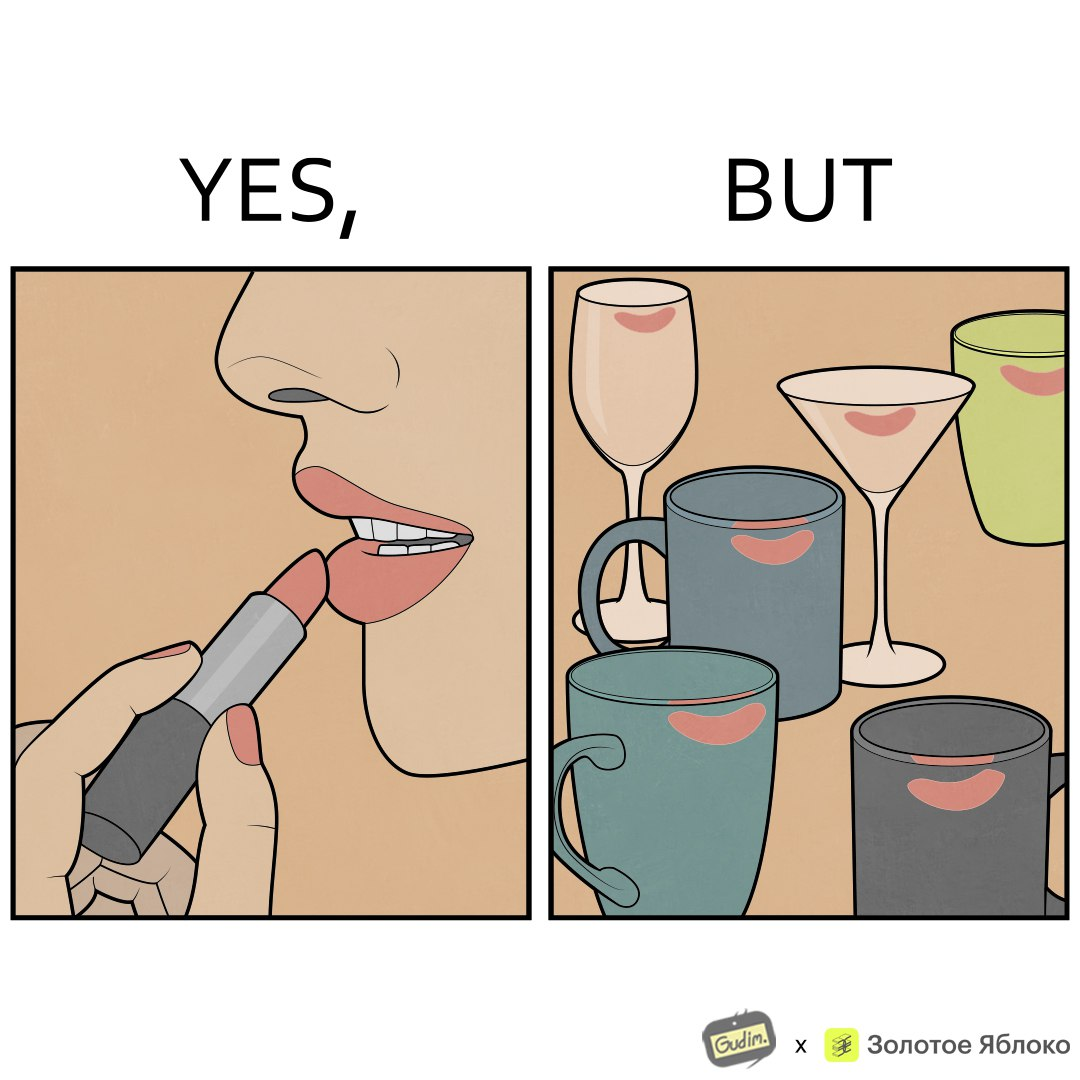Explain the humor or irony in this image. The image is ironic, because the left image suggest that a person applies lipsticks on their lips to make their lips look attractive or to keep them hydrated but on the contrary it gets sticked to the glasses or mugs and gets wasted 